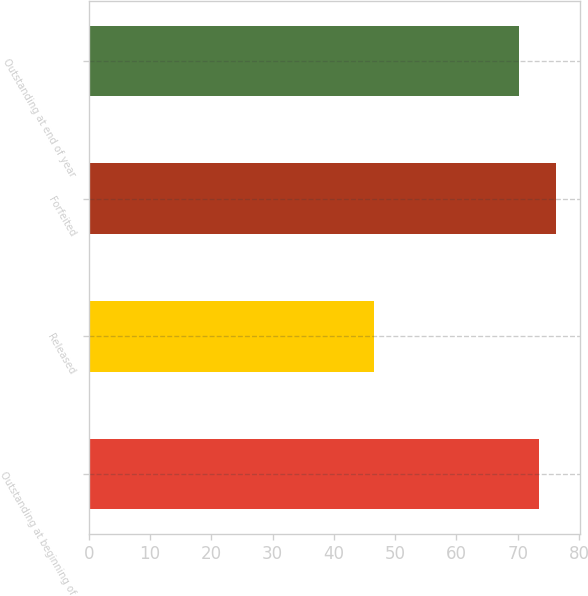Convert chart to OTSL. <chart><loc_0><loc_0><loc_500><loc_500><bar_chart><fcel>Outstanding at beginning of<fcel>Released<fcel>Forfeited<fcel>Outstanding at end of year<nl><fcel>73.4<fcel>46.58<fcel>76.32<fcel>70.14<nl></chart> 